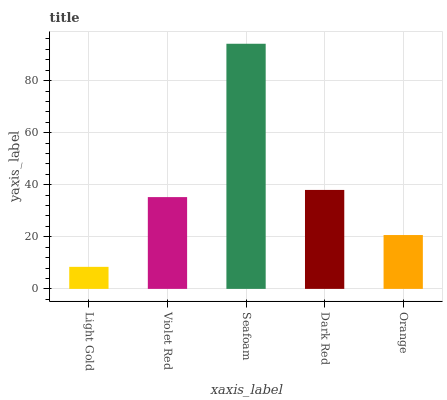Is Light Gold the minimum?
Answer yes or no. Yes. Is Seafoam the maximum?
Answer yes or no. Yes. Is Violet Red the minimum?
Answer yes or no. No. Is Violet Red the maximum?
Answer yes or no. No. Is Violet Red greater than Light Gold?
Answer yes or no. Yes. Is Light Gold less than Violet Red?
Answer yes or no. Yes. Is Light Gold greater than Violet Red?
Answer yes or no. No. Is Violet Red less than Light Gold?
Answer yes or no. No. Is Violet Red the high median?
Answer yes or no. Yes. Is Violet Red the low median?
Answer yes or no. Yes. Is Orange the high median?
Answer yes or no. No. Is Orange the low median?
Answer yes or no. No. 